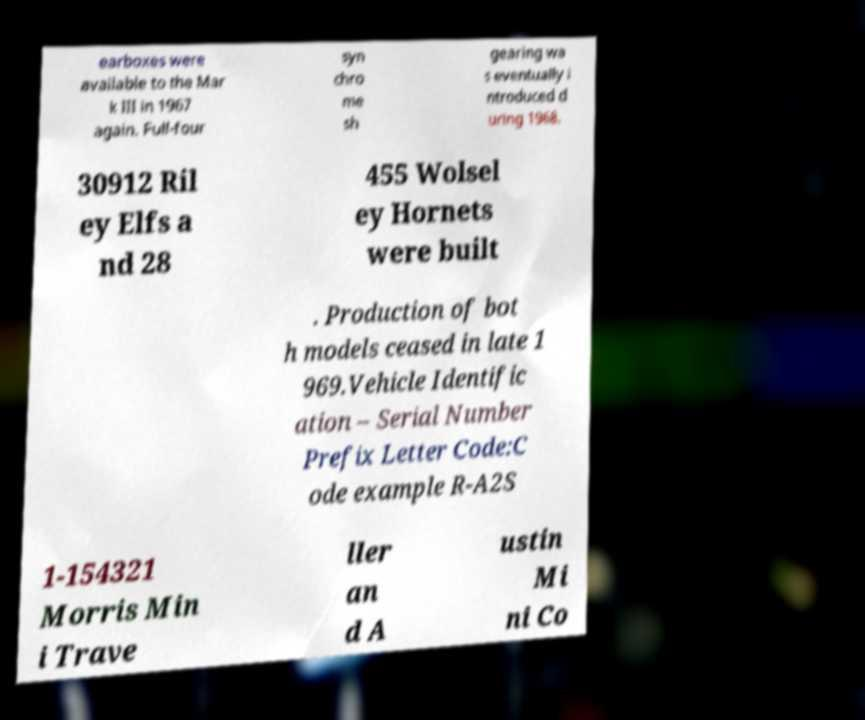Please read and relay the text visible in this image. What does it say? earboxes were available to the Mar k III in 1967 again. Full-four syn chro me sh gearing wa s eventually i ntroduced d uring 1968. 30912 Ril ey Elfs a nd 28 455 Wolsel ey Hornets were built . Production of bot h models ceased in late 1 969.Vehicle Identific ation – Serial Number Prefix Letter Code:C ode example R-A2S 1-154321 Morris Min i Trave ller an d A ustin Mi ni Co 